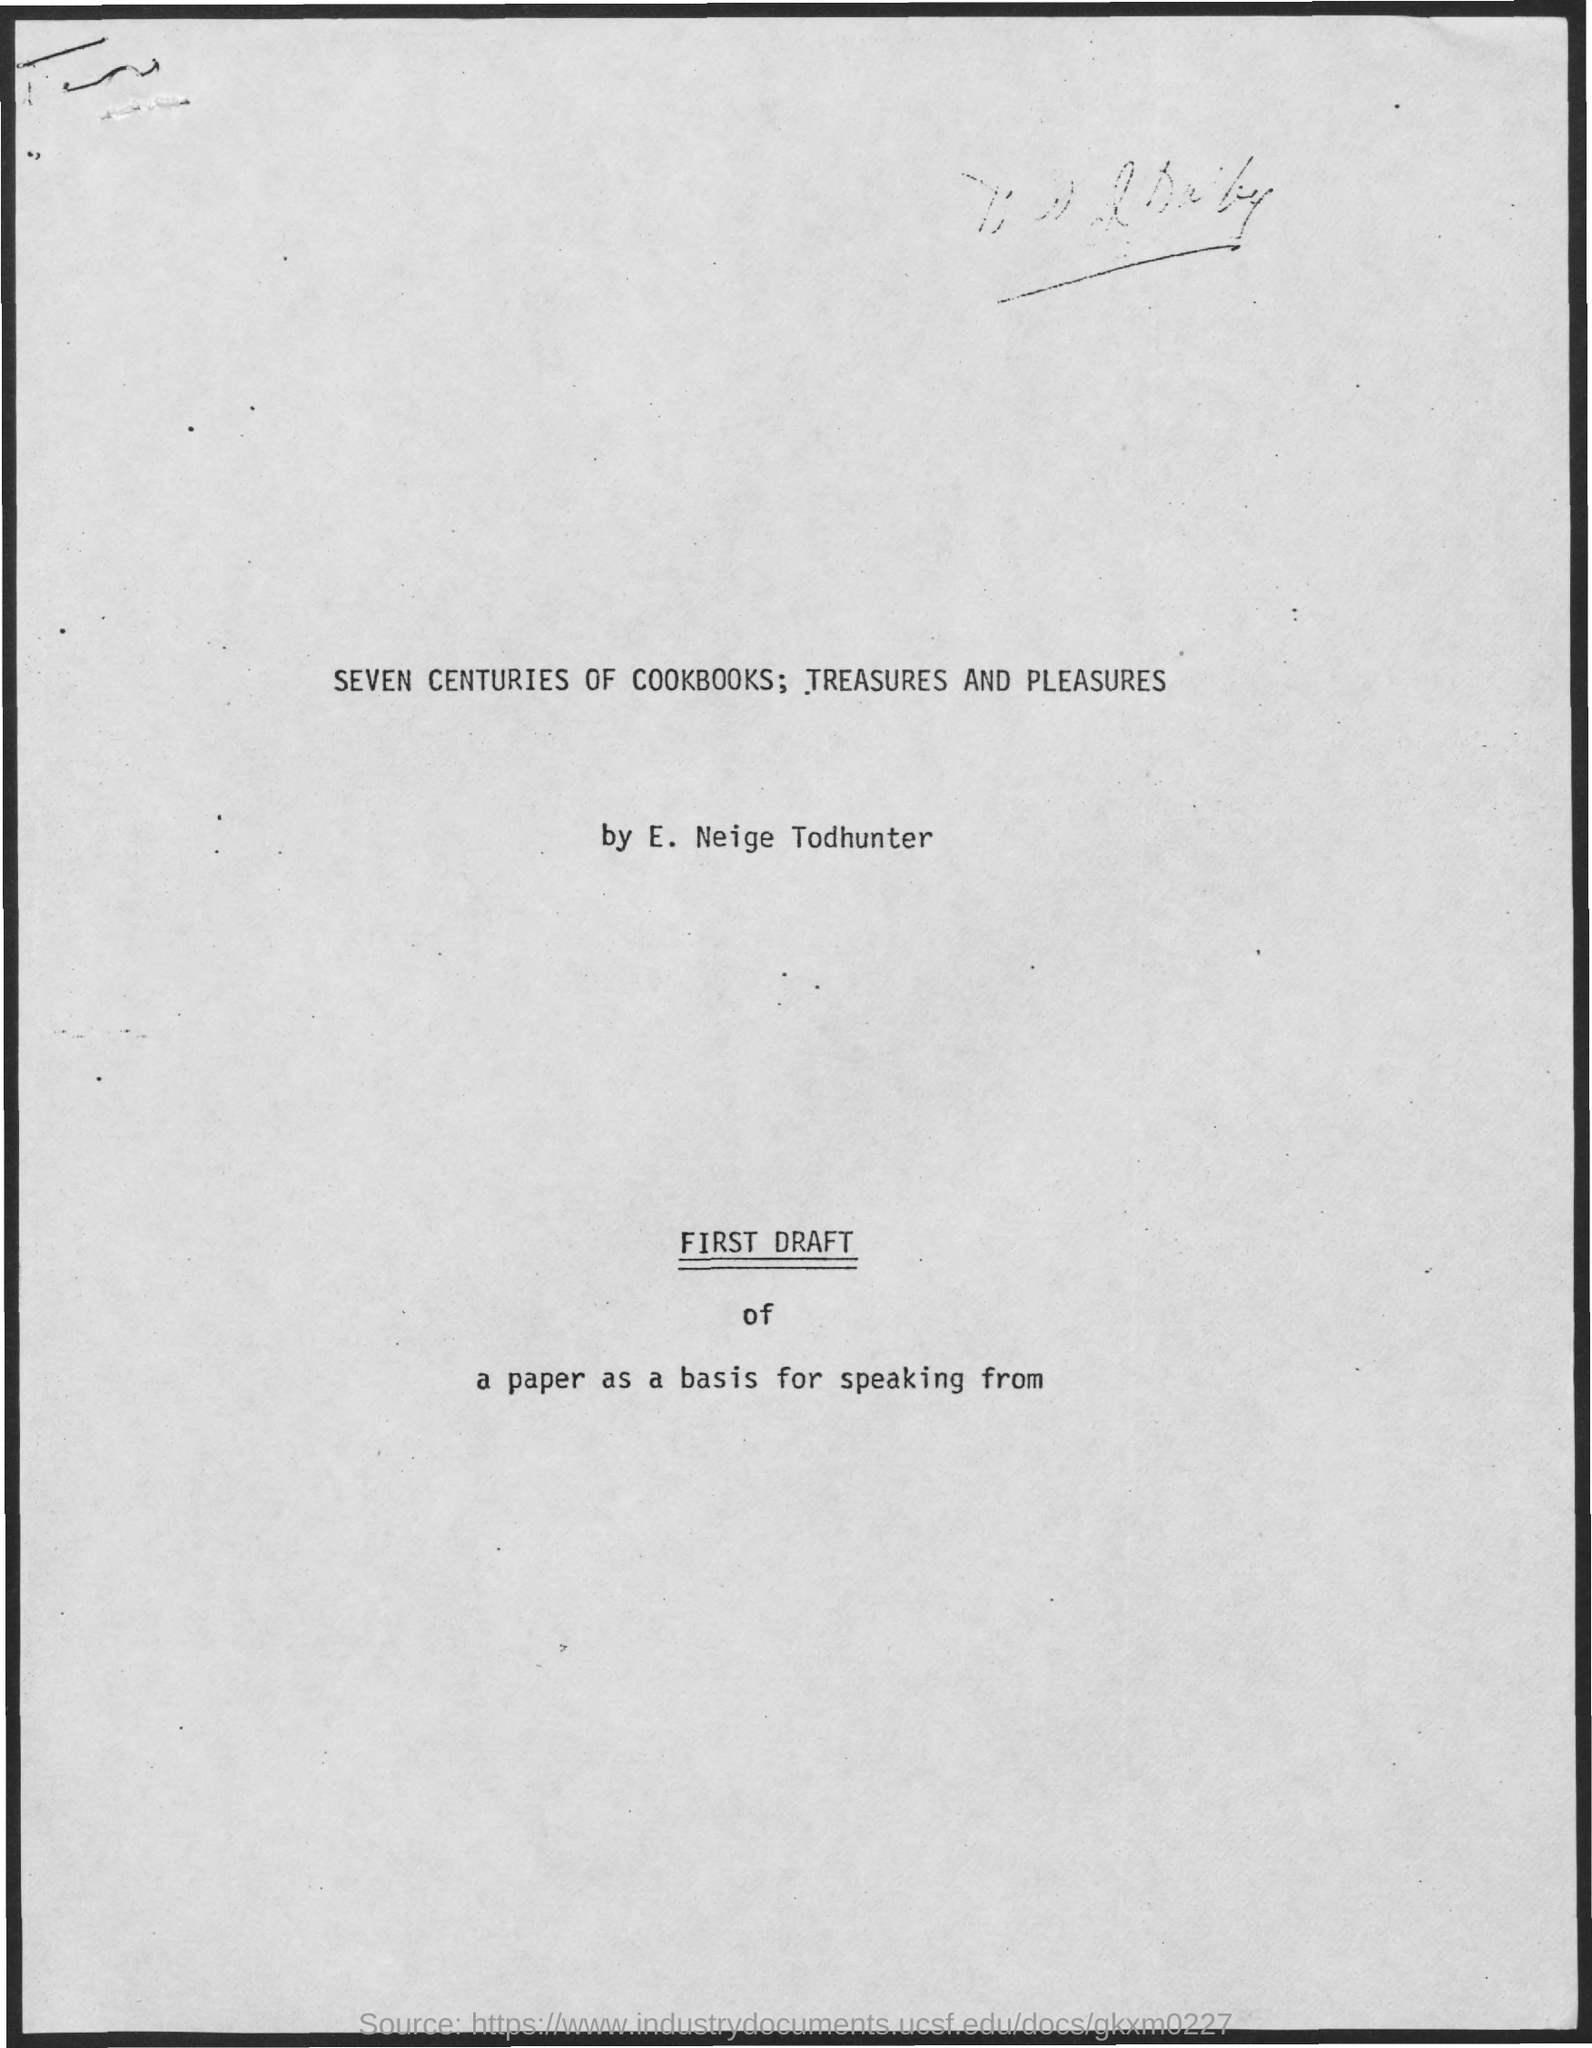Point out several critical features in this image. The person who submitted the report is E. Neige Todhunter. The title of the document is "Seven Centuries of Cookbooks; Treasures and Pleasures.. 